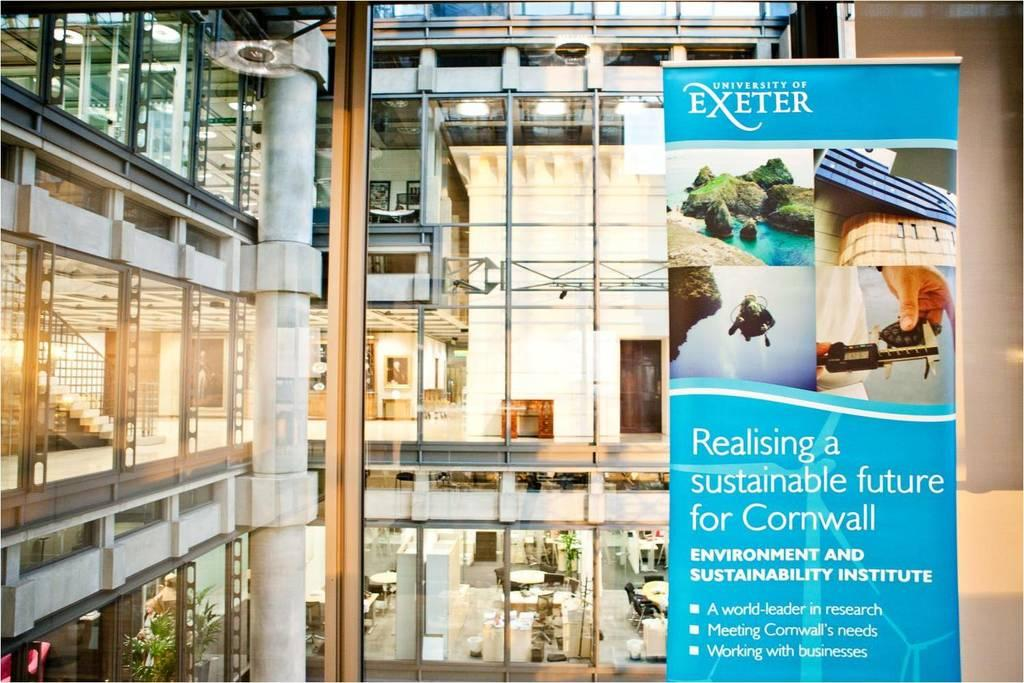<image>
Write a terse but informative summary of the picture. A banner advertising the University of Exeter hangs in a building. 